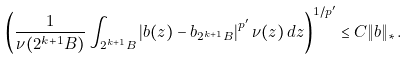<formula> <loc_0><loc_0><loc_500><loc_500>\left ( \frac { 1 } { \nu ( 2 ^ { k + 1 } B ) } \int _ { 2 ^ { k + 1 } B } \left | b ( z ) - b _ { 2 ^ { k + 1 } B } \right | ^ { p ^ { \prime } } \nu ( z ) \, d z \right ) ^ { 1 / { p ^ { \prime } } } \leq C \| b \| _ { * } .</formula> 